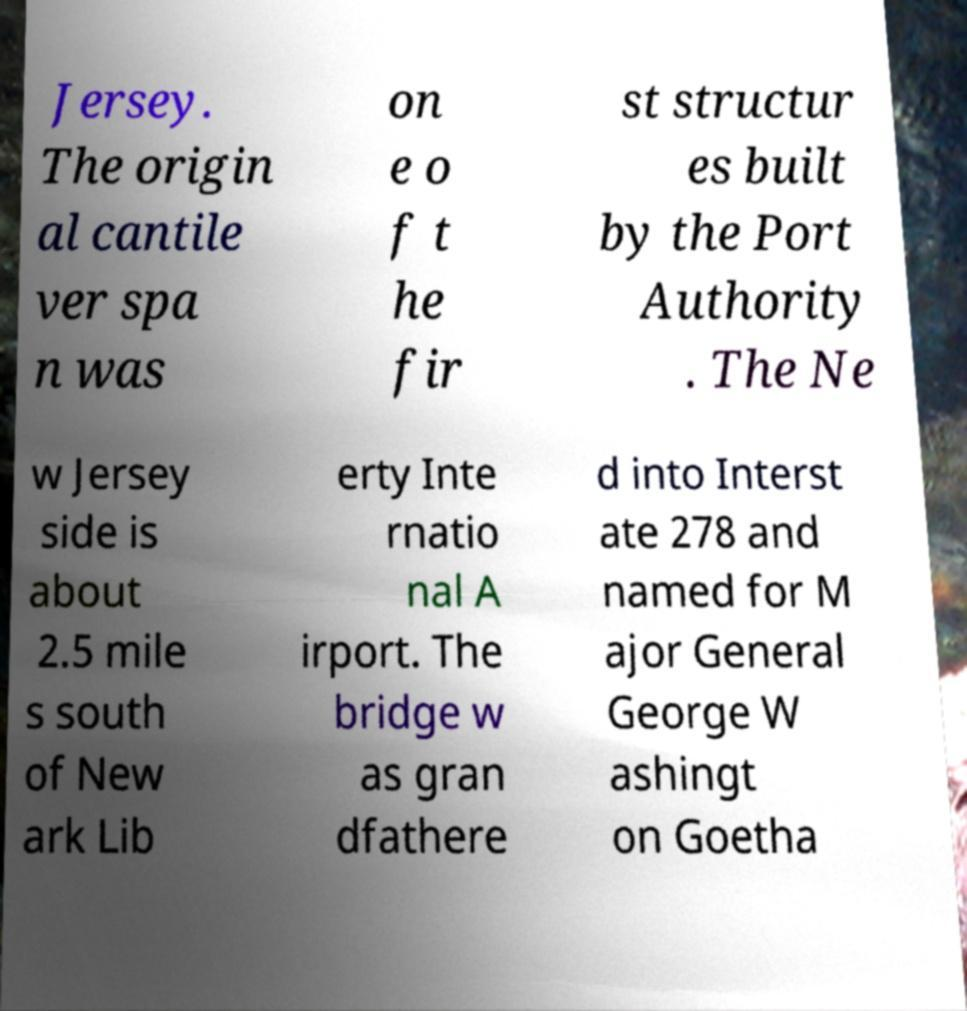Can you accurately transcribe the text from the provided image for me? Jersey. The origin al cantile ver spa n was on e o f t he fir st structur es built by the Port Authority . The Ne w Jersey side is about 2.5 mile s south of New ark Lib erty Inte rnatio nal A irport. The bridge w as gran dfathere d into Interst ate 278 and named for M ajor General George W ashingt on Goetha 